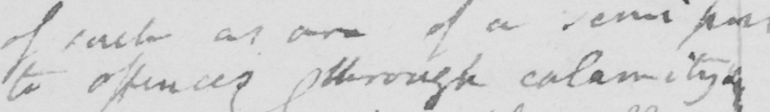Please transcribe the handwritten text in this image. to offences through calamity . 